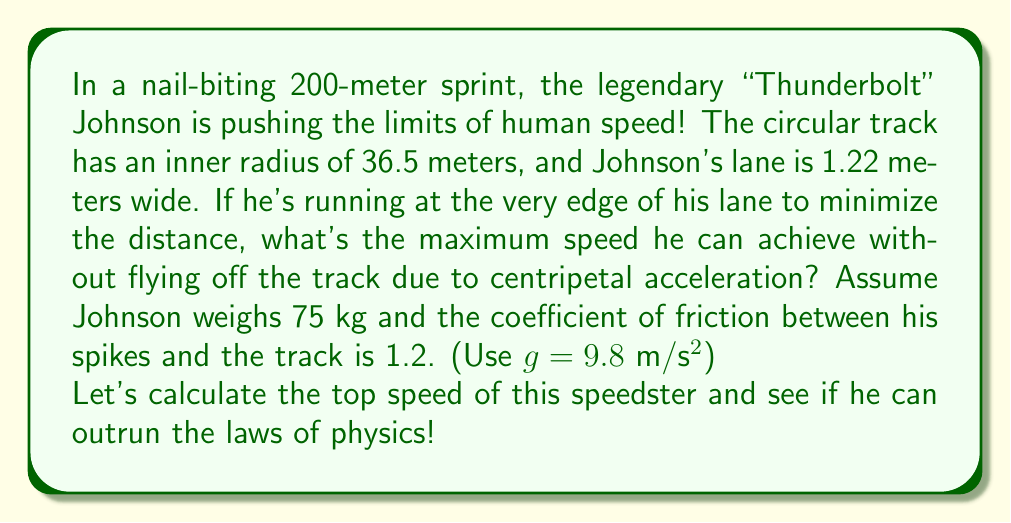Could you help me with this problem? Let's break this down step-by-step, adding some flair to our physics!

1) First, we need to determine the radius of Johnson's path. He's running at the outer edge of his lane:
   $$ R = 36.5 \text{ m} + 1.22 \text{ m} = 37.72 \text{ m} $$

2) The centripetal force needed to keep Johnson on his circular path is given by:
   $$ F_c = \frac{mv^2}{R} $$
   where $m$ is mass, $v$ is velocity, and $R$ is radius.

3) This force is provided by friction between Johnson's shoes and the track. The maximum friction force is:
   $$ F_f = \mu mg $$
   where $\mu$ is the coefficient of friction and $g$ is acceleration due to gravity.

4) At the maximum speed, these forces are equal:
   $$ \frac{mv^2}{R} = \mu mg $$

5) Solving for $v$:
   $$ v^2 = \mu gR $$
   $$ v = \sqrt{\mu gR} $$

6) Plugging in our values:
   $$ v = \sqrt{1.2 \cdot 9.8 \text{ m/s²} \cdot 37.72 \text{ m}} $$
   $$ v = \sqrt{443.5968 \text{ m²/s²}} $$
   $$ v \approx 21.06 \text{ m/s} $$

7) Converting to km/h for a more relatable speed:
   $$ 21.06 \text{ m/s} \cdot \frac{3600 \text{ s}}{1 \text{ h}} \cdot \frac{1 \text{ km}}{1000 \text{ m}} \approx 75.82 \text{ km/h} $$

And there you have it! Johnson's top speed before he risks becoming a human discus!
Answer: The maximum speed "Thunderbolt" Johnson can achieve is approximately 21.06 m/s or 75.82 km/h. 